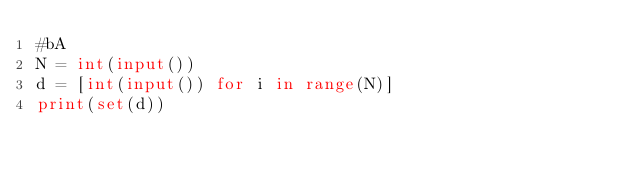Convert code to text. <code><loc_0><loc_0><loc_500><loc_500><_Python_>#bA
N = int(input())
d = [int(input()) for i in range(N)]
print(set(d))</code> 